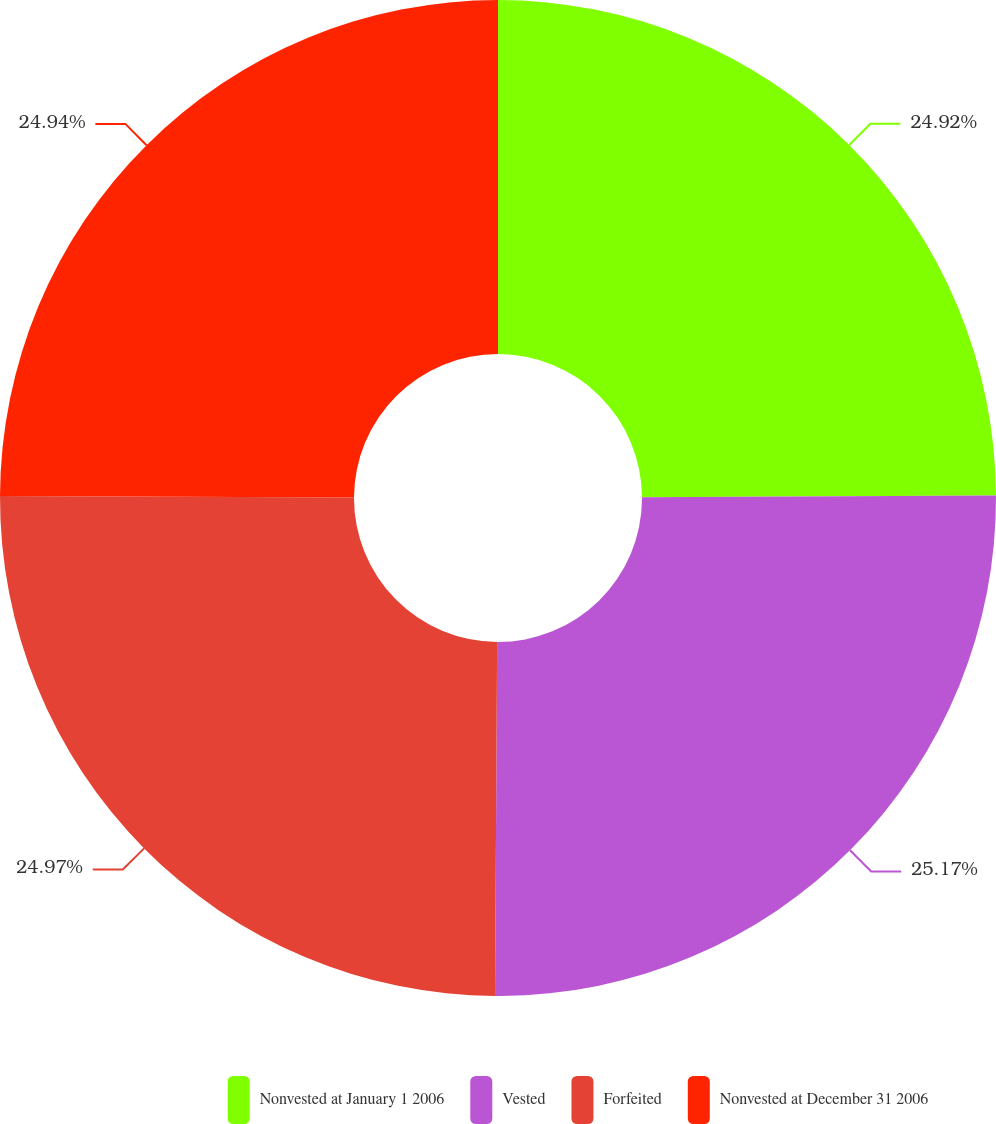Convert chart to OTSL. <chart><loc_0><loc_0><loc_500><loc_500><pie_chart><fcel>Nonvested at January 1 2006<fcel>Vested<fcel>Forfeited<fcel>Nonvested at December 31 2006<nl><fcel>24.92%<fcel>25.18%<fcel>24.97%<fcel>24.94%<nl></chart> 